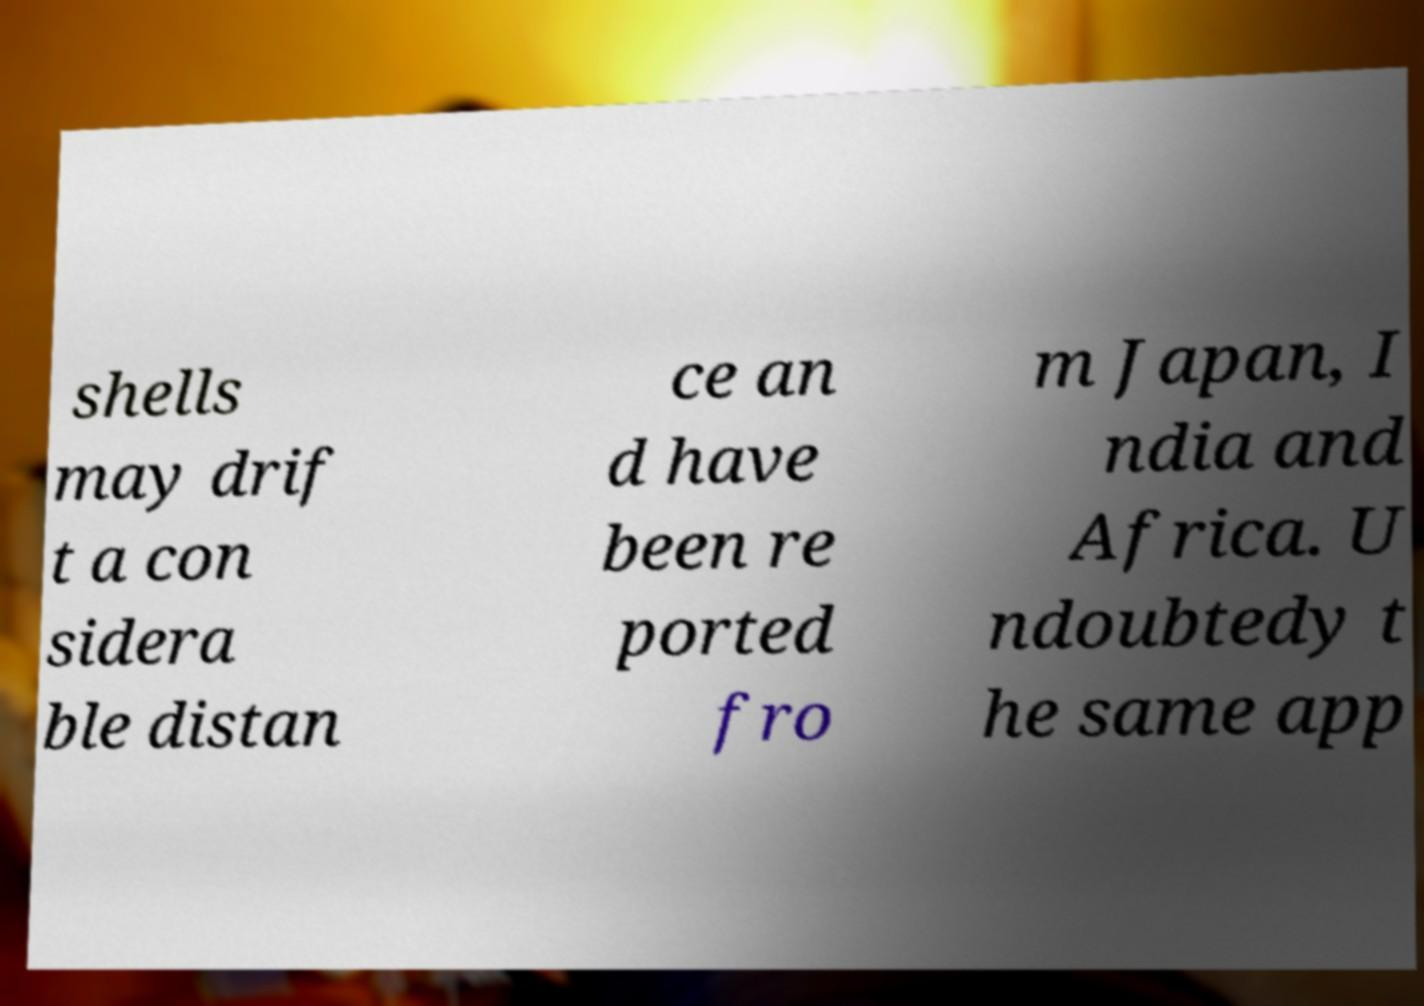Please read and relay the text visible in this image. What does it say? shells may drif t a con sidera ble distan ce an d have been re ported fro m Japan, I ndia and Africa. U ndoubtedy t he same app 